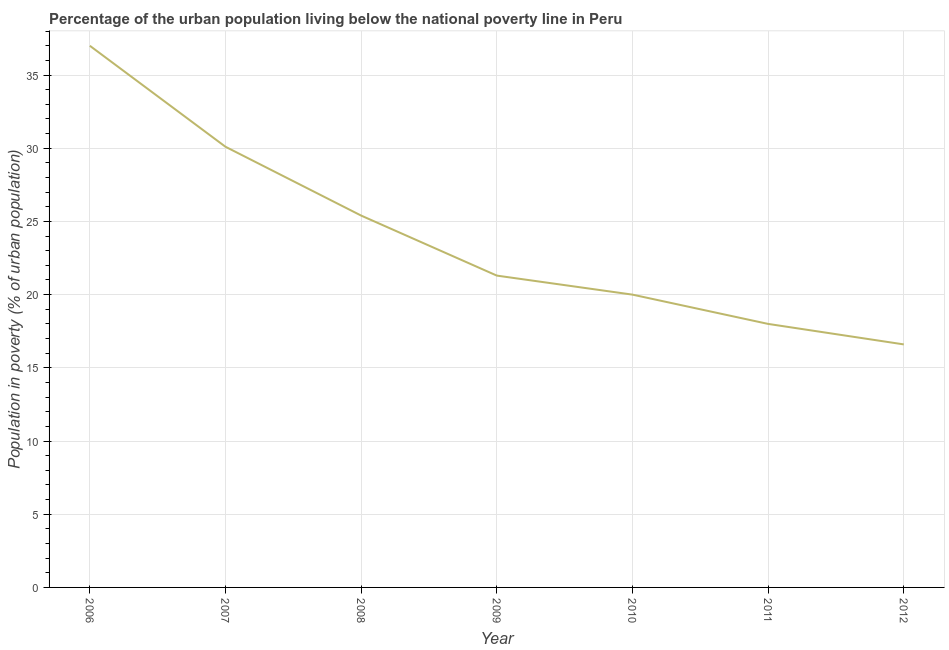What is the percentage of urban population living below poverty line in 2008?
Provide a short and direct response. 25.4. In which year was the percentage of urban population living below poverty line minimum?
Offer a very short reply. 2012. What is the sum of the percentage of urban population living below poverty line?
Your response must be concise. 168.4. What is the difference between the percentage of urban population living below poverty line in 2009 and 2012?
Give a very brief answer. 4.7. What is the average percentage of urban population living below poverty line per year?
Provide a succinct answer. 24.06. What is the median percentage of urban population living below poverty line?
Make the answer very short. 21.3. In how many years, is the percentage of urban population living below poverty line greater than 26 %?
Ensure brevity in your answer.  2. What is the ratio of the percentage of urban population living below poverty line in 2009 to that in 2010?
Your response must be concise. 1.06. Is the percentage of urban population living below poverty line in 2007 less than that in 2011?
Give a very brief answer. No. Is the difference between the percentage of urban population living below poverty line in 2007 and 2008 greater than the difference between any two years?
Keep it short and to the point. No. What is the difference between the highest and the second highest percentage of urban population living below poverty line?
Provide a succinct answer. 6.9. Is the sum of the percentage of urban population living below poverty line in 2010 and 2012 greater than the maximum percentage of urban population living below poverty line across all years?
Keep it short and to the point. No. What is the difference between the highest and the lowest percentage of urban population living below poverty line?
Offer a very short reply. 20.4. In how many years, is the percentage of urban population living below poverty line greater than the average percentage of urban population living below poverty line taken over all years?
Give a very brief answer. 3. How many years are there in the graph?
Give a very brief answer. 7. What is the difference between two consecutive major ticks on the Y-axis?
Your answer should be very brief. 5. Are the values on the major ticks of Y-axis written in scientific E-notation?
Make the answer very short. No. Does the graph contain grids?
Provide a short and direct response. Yes. What is the title of the graph?
Provide a short and direct response. Percentage of the urban population living below the national poverty line in Peru. What is the label or title of the Y-axis?
Make the answer very short. Population in poverty (% of urban population). What is the Population in poverty (% of urban population) in 2006?
Offer a very short reply. 37. What is the Population in poverty (% of urban population) of 2007?
Ensure brevity in your answer.  30.1. What is the Population in poverty (% of urban population) in 2008?
Provide a short and direct response. 25.4. What is the Population in poverty (% of urban population) in 2009?
Offer a terse response. 21.3. What is the Population in poverty (% of urban population) in 2012?
Offer a terse response. 16.6. What is the difference between the Population in poverty (% of urban population) in 2006 and 2011?
Give a very brief answer. 19. What is the difference between the Population in poverty (% of urban population) in 2006 and 2012?
Keep it short and to the point. 20.4. What is the difference between the Population in poverty (% of urban population) in 2007 and 2008?
Offer a terse response. 4.7. What is the difference between the Population in poverty (% of urban population) in 2007 and 2011?
Offer a terse response. 12.1. What is the difference between the Population in poverty (% of urban population) in 2008 and 2011?
Make the answer very short. 7.4. What is the difference between the Population in poverty (% of urban population) in 2009 and 2010?
Keep it short and to the point. 1.3. What is the difference between the Population in poverty (% of urban population) in 2009 and 2011?
Give a very brief answer. 3.3. What is the difference between the Population in poverty (% of urban population) in 2011 and 2012?
Your answer should be compact. 1.4. What is the ratio of the Population in poverty (% of urban population) in 2006 to that in 2007?
Keep it short and to the point. 1.23. What is the ratio of the Population in poverty (% of urban population) in 2006 to that in 2008?
Keep it short and to the point. 1.46. What is the ratio of the Population in poverty (% of urban population) in 2006 to that in 2009?
Offer a terse response. 1.74. What is the ratio of the Population in poverty (% of urban population) in 2006 to that in 2010?
Give a very brief answer. 1.85. What is the ratio of the Population in poverty (% of urban population) in 2006 to that in 2011?
Your answer should be compact. 2.06. What is the ratio of the Population in poverty (% of urban population) in 2006 to that in 2012?
Your answer should be compact. 2.23. What is the ratio of the Population in poverty (% of urban population) in 2007 to that in 2008?
Ensure brevity in your answer.  1.19. What is the ratio of the Population in poverty (% of urban population) in 2007 to that in 2009?
Your response must be concise. 1.41. What is the ratio of the Population in poverty (% of urban population) in 2007 to that in 2010?
Make the answer very short. 1.5. What is the ratio of the Population in poverty (% of urban population) in 2007 to that in 2011?
Provide a short and direct response. 1.67. What is the ratio of the Population in poverty (% of urban population) in 2007 to that in 2012?
Keep it short and to the point. 1.81. What is the ratio of the Population in poverty (% of urban population) in 2008 to that in 2009?
Offer a terse response. 1.19. What is the ratio of the Population in poverty (% of urban population) in 2008 to that in 2010?
Your response must be concise. 1.27. What is the ratio of the Population in poverty (% of urban population) in 2008 to that in 2011?
Your response must be concise. 1.41. What is the ratio of the Population in poverty (% of urban population) in 2008 to that in 2012?
Provide a short and direct response. 1.53. What is the ratio of the Population in poverty (% of urban population) in 2009 to that in 2010?
Provide a succinct answer. 1.06. What is the ratio of the Population in poverty (% of urban population) in 2009 to that in 2011?
Keep it short and to the point. 1.18. What is the ratio of the Population in poverty (% of urban population) in 2009 to that in 2012?
Make the answer very short. 1.28. What is the ratio of the Population in poverty (% of urban population) in 2010 to that in 2011?
Your response must be concise. 1.11. What is the ratio of the Population in poverty (% of urban population) in 2010 to that in 2012?
Offer a terse response. 1.21. What is the ratio of the Population in poverty (% of urban population) in 2011 to that in 2012?
Ensure brevity in your answer.  1.08. 